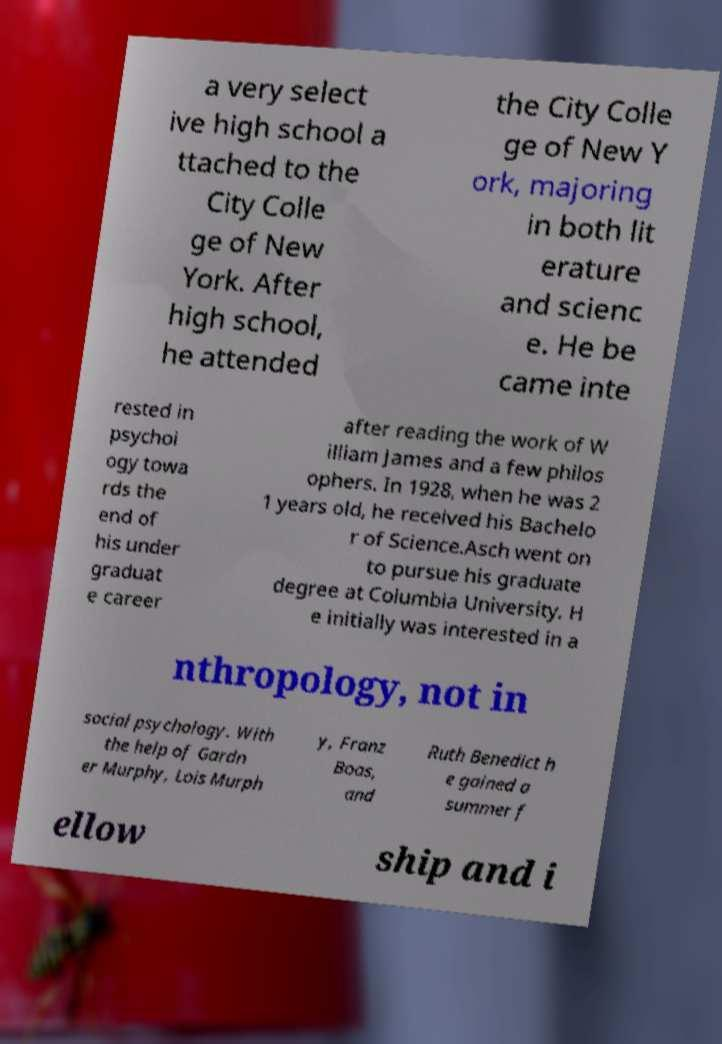Could you assist in decoding the text presented in this image and type it out clearly? a very select ive high school a ttached to the City Colle ge of New York. After high school, he attended the City Colle ge of New Y ork, majoring in both lit erature and scienc e. He be came inte rested in psychol ogy towa rds the end of his under graduat e career after reading the work of W illiam James and a few philos ophers. In 1928, when he was 2 1 years old, he received his Bachelo r of Science.Asch went on to pursue his graduate degree at Columbia University. H e initially was interested in a nthropology, not in social psychology. With the help of Gardn er Murphy, Lois Murph y, Franz Boas, and Ruth Benedict h e gained a summer f ellow ship and i 